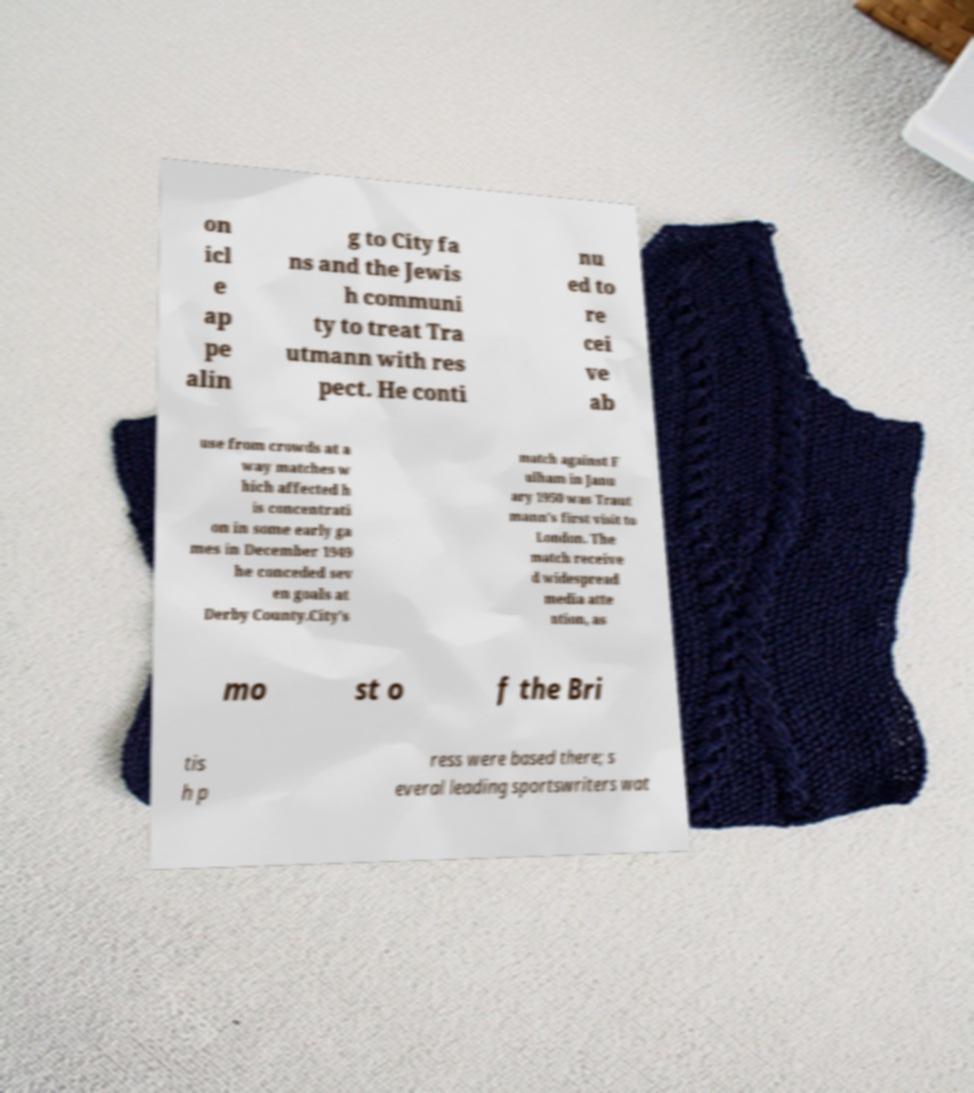I need the written content from this picture converted into text. Can you do that? on icl e ap pe alin g to City fa ns and the Jewis h communi ty to treat Tra utmann with res pect. He conti nu ed to re cei ve ab use from crowds at a way matches w hich affected h is concentrati on in some early ga mes in December 1949 he conceded sev en goals at Derby County.City's match against F ulham in Janu ary 1950 was Traut mann's first visit to London. The match receive d widespread media atte ntion, as mo st o f the Bri tis h p ress were based there; s everal leading sportswriters wat 